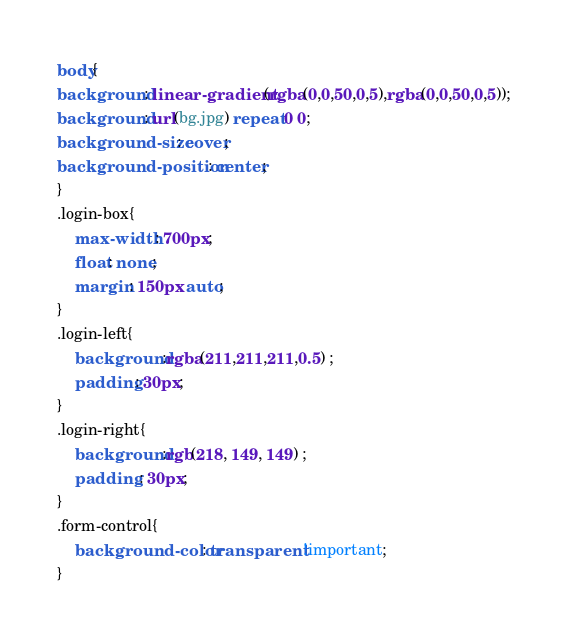Convert code to text. <code><loc_0><loc_0><loc_500><loc_500><_CSS_>body{
background: linear-gradient(rgba(0,0,50,0,5),rgba(0,0,50,0,5));
background: url(bg.jpg) repeat 0 0;
background-size: cover;
background-position: center;
}
.login-box{
    max-width: 700px;
    float: none;
    margin: 150px auto;
}
.login-left{
    background:rgba(211,211,211,0.5) ;
    padding: 30px;
}
.login-right{
    background:rgb(218, 149, 149) ;
    padding : 30px;
}
.form-control{
    background-color: transparent !important;
}</code> 